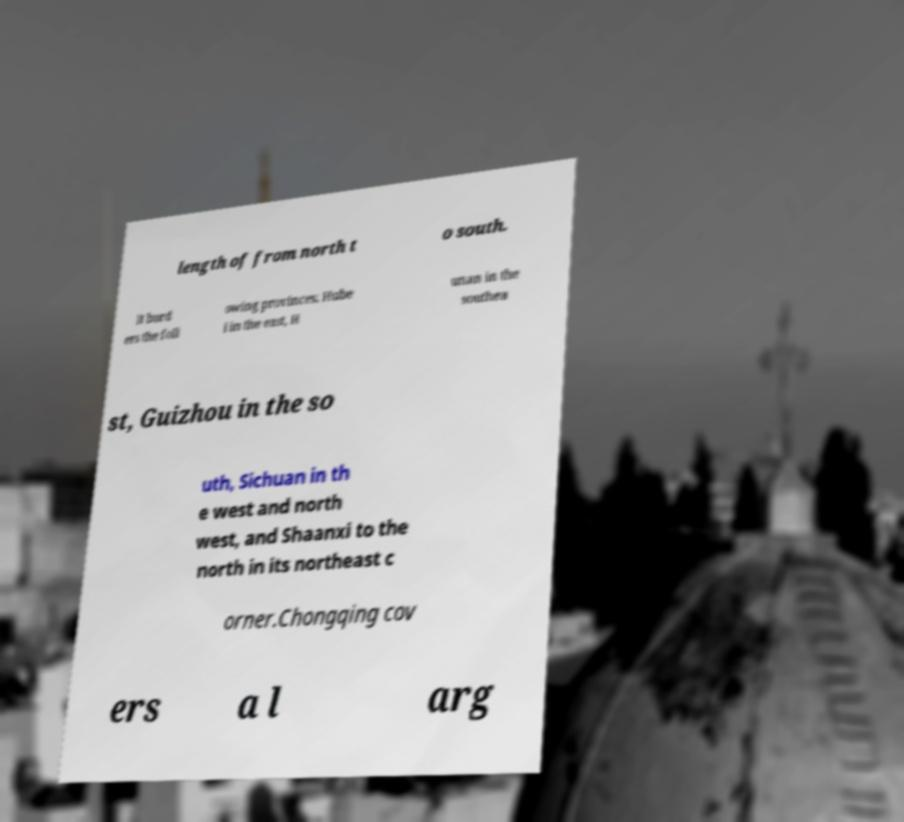Can you accurately transcribe the text from the provided image for me? length of from north t o south. It bord ers the foll owing provinces: Hube i in the east, H unan in the southea st, Guizhou in the so uth, Sichuan in th e west and north west, and Shaanxi to the north in its northeast c orner.Chongqing cov ers a l arg 